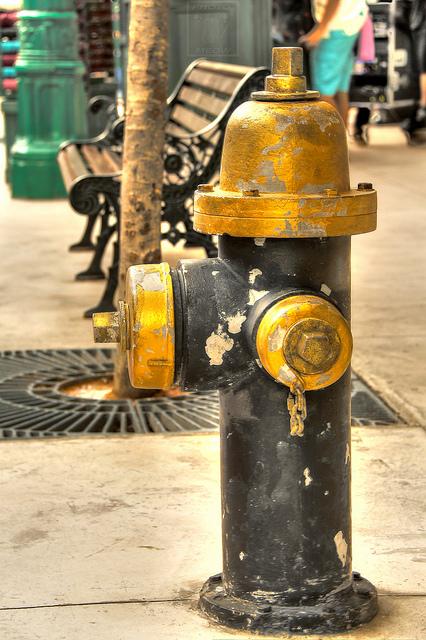Is there any grass?
Be succinct. No. Is the fire hydrant new?
Quick response, please. No. What is growing up from the ground just behind the fire hydrant?
Give a very brief answer. Tree. 